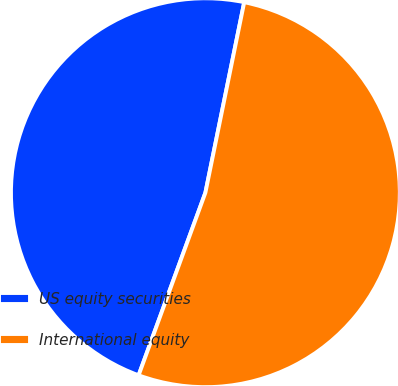<chart> <loc_0><loc_0><loc_500><loc_500><pie_chart><fcel>US equity securities<fcel>International equity<nl><fcel>47.62%<fcel>52.38%<nl></chart> 